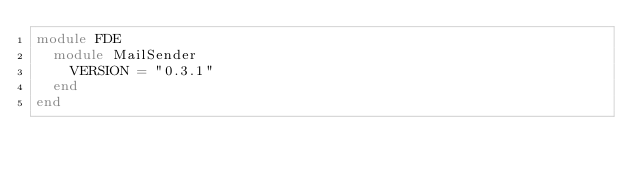Convert code to text. <code><loc_0><loc_0><loc_500><loc_500><_Ruby_>module FDE
  module MailSender
    VERSION = "0.3.1"
  end
end
</code> 